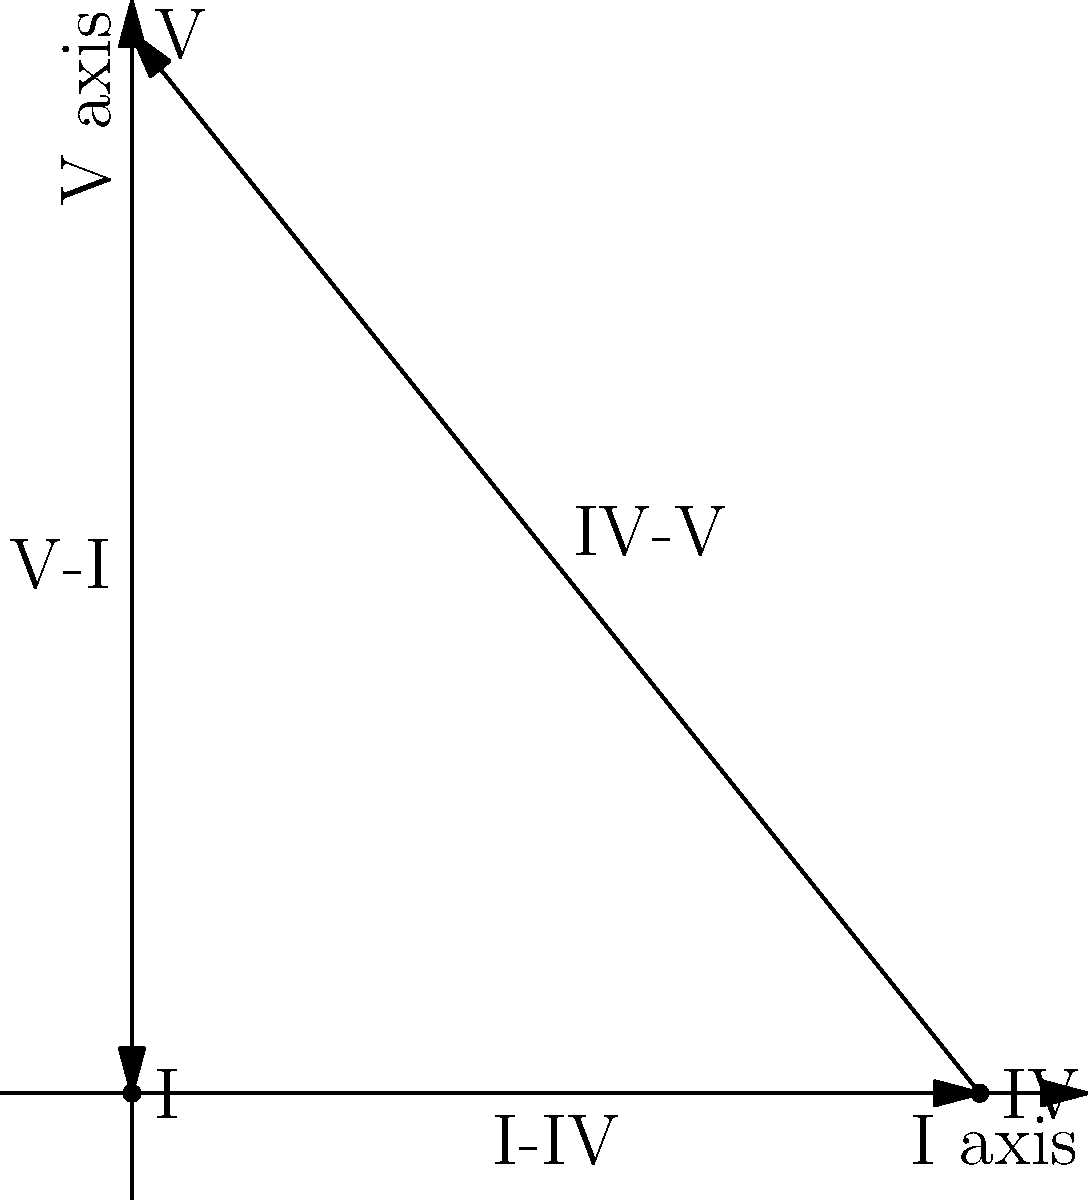In the given 2D space representation of chord progressions, where the x-axis represents the I chord and the y-axis represents the V chord, what is the magnitude of the vector representing the IV-V progression? To find the magnitude of the IV-V vector, we need to follow these steps:

1. Identify the coordinates of the IV and V chords:
   IV: (4, 0)
   V: (0, 5)

2. Calculate the displacement vector from IV to V:
   $\vec{IV-V} = (0-4, 5-0) = (-4, 5)$

3. Use the Pythagorean theorem to calculate the magnitude:
   $\text{magnitude} = \sqrt{(-4)^2 + 5^2}$

4. Simplify:
   $\text{magnitude} = \sqrt{16 + 25} = \sqrt{41}$

Therefore, the magnitude of the IV-V vector is $\sqrt{41}$.
Answer: $\sqrt{41}$ 